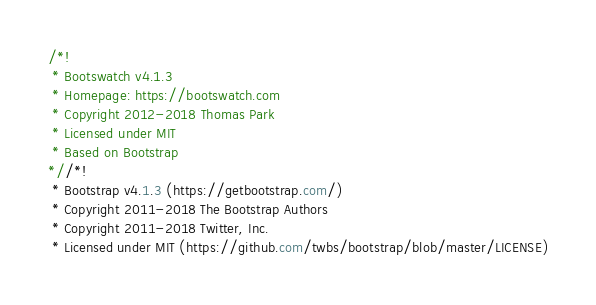Convert code to text. <code><loc_0><loc_0><loc_500><loc_500><_CSS_>/*!
 * Bootswatch v4.1.3
 * Homepage: https://bootswatch.com
 * Copyright 2012-2018 Thomas Park
 * Licensed under MIT
 * Based on Bootstrap
*//*!
 * Bootstrap v4.1.3 (https://getbootstrap.com/)
 * Copyright 2011-2018 The Bootstrap Authors
 * Copyright 2011-2018 Twitter, Inc.
 * Licensed under MIT (https://github.com/twbs/bootstrap/blob/master/LICENSE)</code> 